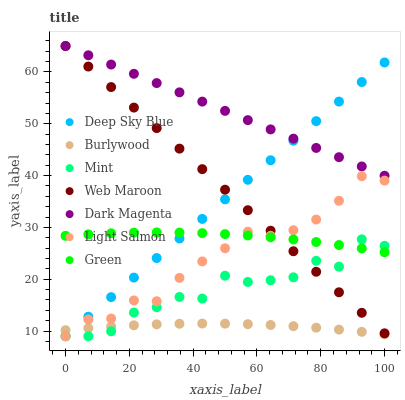Does Burlywood have the minimum area under the curve?
Answer yes or no. Yes. Does Dark Magenta have the maximum area under the curve?
Answer yes or no. Yes. Does Dark Magenta have the minimum area under the curve?
Answer yes or no. No. Does Burlywood have the maximum area under the curve?
Answer yes or no. No. Is Dark Magenta the smoothest?
Answer yes or no. Yes. Is Mint the roughest?
Answer yes or no. Yes. Is Burlywood the smoothest?
Answer yes or no. No. Is Burlywood the roughest?
Answer yes or no. No. Does Light Salmon have the lowest value?
Answer yes or no. Yes. Does Burlywood have the lowest value?
Answer yes or no. No. Does Web Maroon have the highest value?
Answer yes or no. Yes. Does Burlywood have the highest value?
Answer yes or no. No. Is Burlywood less than Web Maroon?
Answer yes or no. Yes. Is Web Maroon greater than Burlywood?
Answer yes or no. Yes. Does Dark Magenta intersect Web Maroon?
Answer yes or no. Yes. Is Dark Magenta less than Web Maroon?
Answer yes or no. No. Is Dark Magenta greater than Web Maroon?
Answer yes or no. No. Does Burlywood intersect Web Maroon?
Answer yes or no. No. 